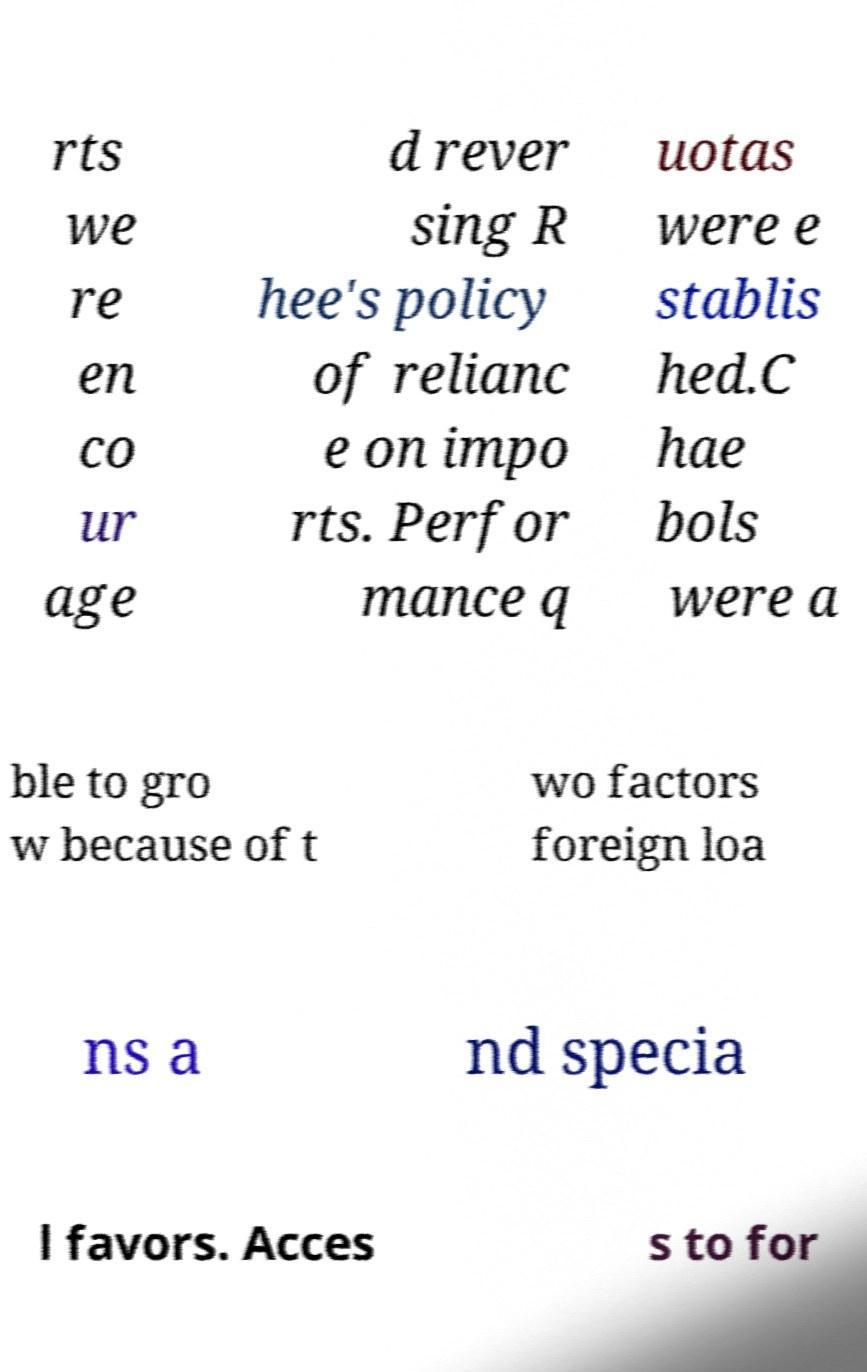Please read and relay the text visible in this image. What does it say? rts we re en co ur age d rever sing R hee's policy of relianc e on impo rts. Perfor mance q uotas were e stablis hed.C hae bols were a ble to gro w because of t wo factors foreign loa ns a nd specia l favors. Acces s to for 